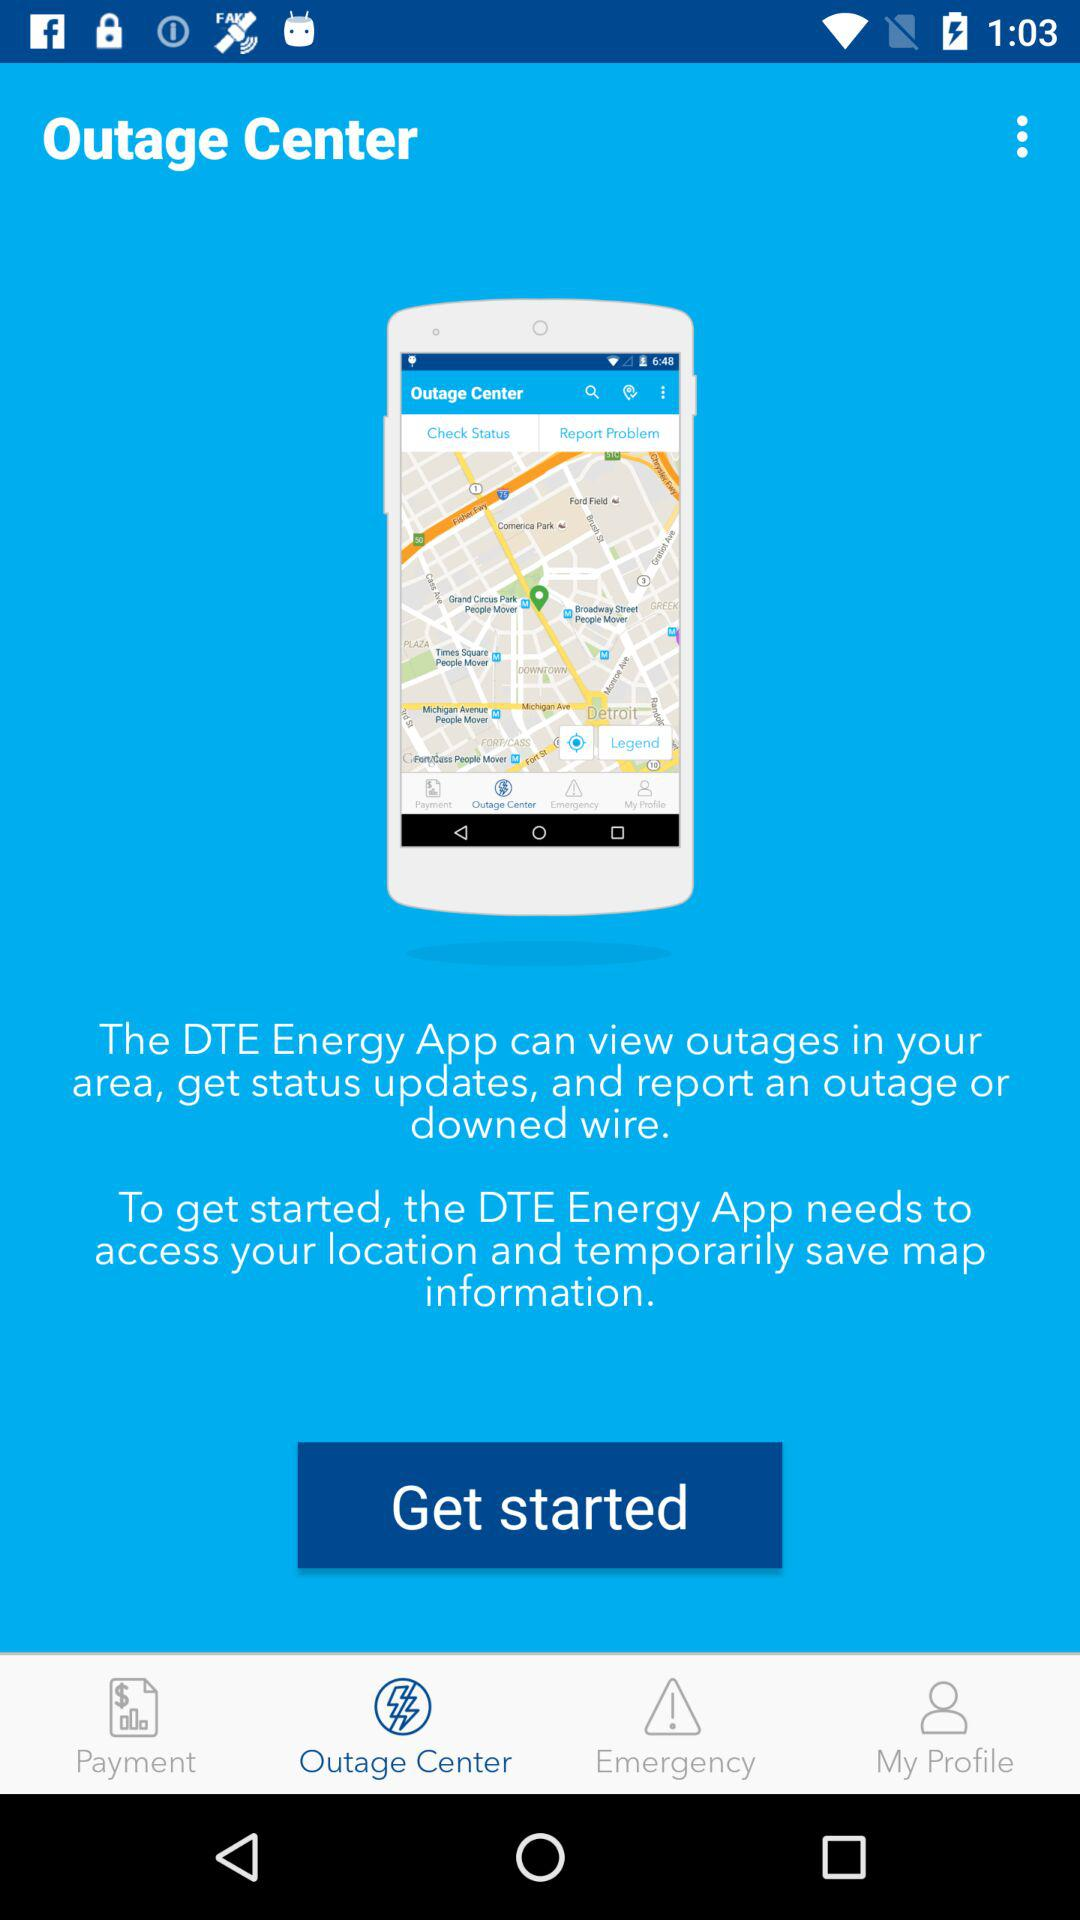What is the name of the application? The name of the application is "DTE Energy". 